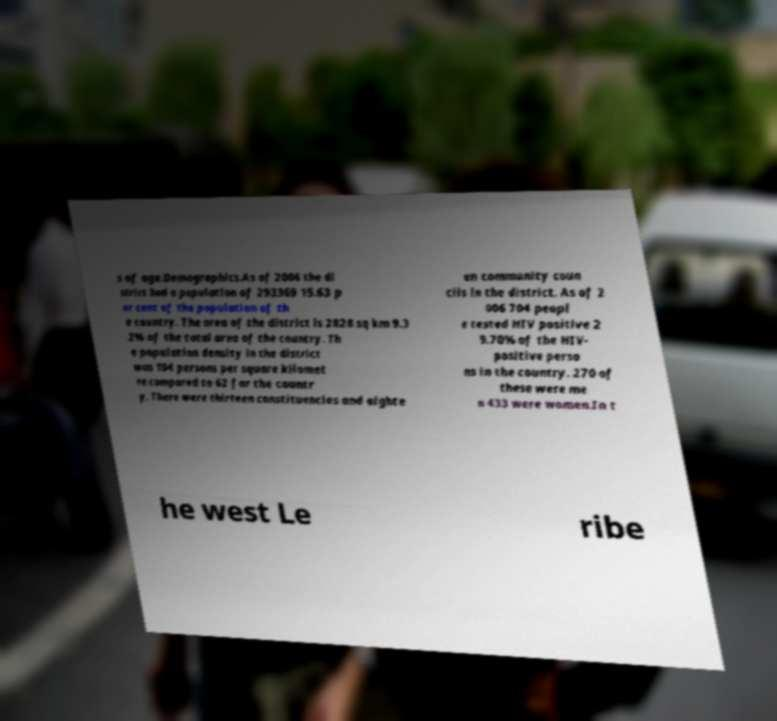There's text embedded in this image that I need extracted. Can you transcribe it verbatim? s of age.Demographics.As of 2006 the di strict had a population of 293369 15.63 p er cent of the population of th e country. The area of the district is 2828 sq km 9.3 2% of the total area of the country. Th e population density in the district was 104 persons per square kilomet re compared to 62 for the countr y. There were thirteen constituencies and eighte en community coun cils in the district. As of 2 006 704 peopl e tested HIV positive 2 9.70% of the HIV- positive perso ns in the country. 270 of these were me n 433 were women.In t he west Le ribe 